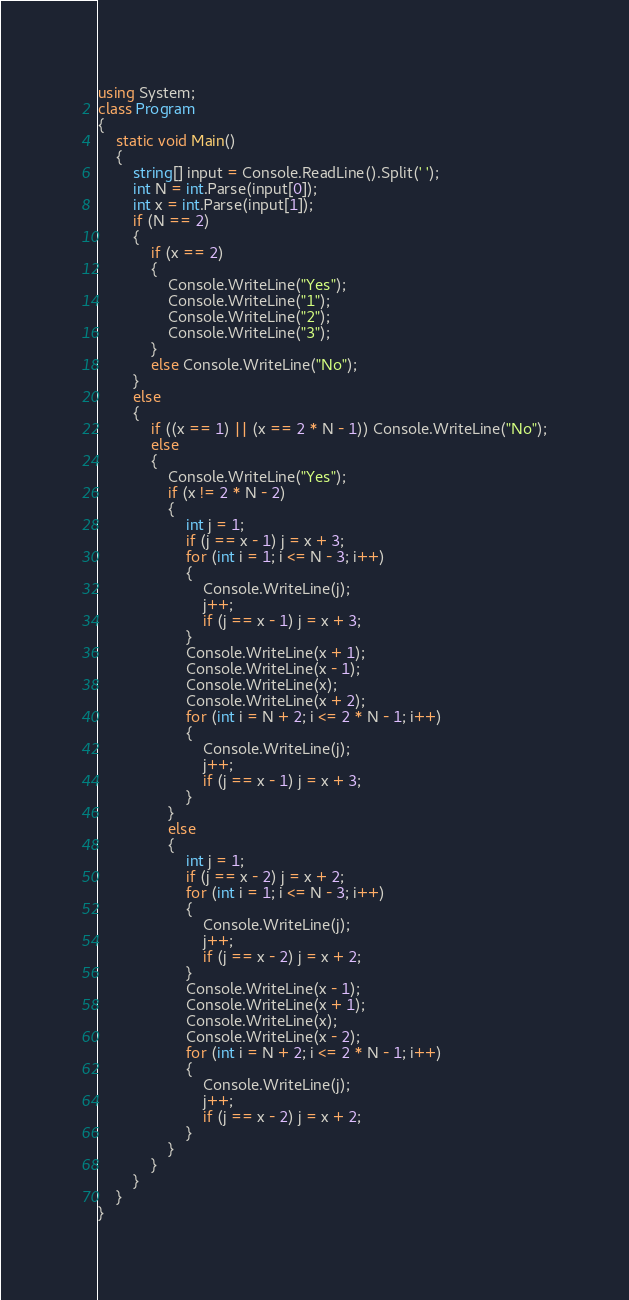Convert code to text. <code><loc_0><loc_0><loc_500><loc_500><_C#_>using System;
class Program
{
    static void Main()
    {
        string[] input = Console.ReadLine().Split(' ');
        int N = int.Parse(input[0]);
        int x = int.Parse(input[1]);
        if (N == 2)
        {
            if (x == 2)
            {
                Console.WriteLine("Yes");
                Console.WriteLine("1");
                Console.WriteLine("2");
                Console.WriteLine("3");
            }
            else Console.WriteLine("No");
        }
        else
        {
            if ((x == 1) || (x == 2 * N - 1)) Console.WriteLine("No");
            else
            {
                Console.WriteLine("Yes");
                if (x != 2 * N - 2)
                {
                    int j = 1;
                    if (j == x - 1) j = x + 3;
                    for (int i = 1; i <= N - 3; i++)
                    {
                        Console.WriteLine(j);
                        j++;
                        if (j == x - 1) j = x + 3;
                    }
                    Console.WriteLine(x + 1);
                    Console.WriteLine(x - 1);
                    Console.WriteLine(x);
                    Console.WriteLine(x + 2);
                    for (int i = N + 2; i <= 2 * N - 1; i++)
                    {
                        Console.WriteLine(j);
                        j++;
                        if (j == x - 1) j = x + 3;
                    }
                }
                else
                {
                    int j = 1;
                    if (j == x - 2) j = x + 2;
                    for (int i = 1; i <= N - 3; i++)
                    {
                        Console.WriteLine(j);
                        j++;
                        if (j == x - 2) j = x + 2;
                    }
                    Console.WriteLine(x - 1);
                    Console.WriteLine(x + 1);
                    Console.WriteLine(x);
                    Console.WriteLine(x - 2);
                    for (int i = N + 2; i <= 2 * N - 1; i++)
                    {
                        Console.WriteLine(j);
                        j++;
                        if (j == x - 2) j = x + 2;
                    }
                }
            }
        }
    }
}</code> 